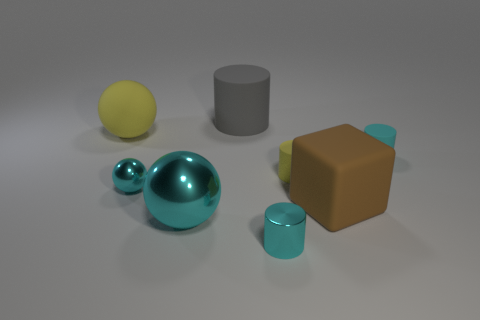Is there anything else that has the same shape as the large cyan metallic object?
Provide a succinct answer. Yes. Does the rubber cylinder that is in front of the cyan matte cylinder have the same size as the small ball?
Keep it short and to the point. Yes. What number of metallic objects are either big yellow balls or small cyan balls?
Your response must be concise. 1. How big is the sphere that is in front of the matte cube?
Keep it short and to the point. Large. Do the brown matte thing and the gray thing have the same shape?
Keep it short and to the point. No. What number of small things are either cyan metal objects or gray things?
Keep it short and to the point. 2. Are there any small rubber things in front of the cube?
Provide a short and direct response. No. Is the number of tiny shiny things to the right of the large gray cylinder the same as the number of brown matte blocks?
Your response must be concise. Yes. There is a gray object that is the same shape as the cyan rubber object; what size is it?
Your response must be concise. Large. Do the small yellow matte object and the small shiny thing behind the big matte cube have the same shape?
Make the answer very short. No. 